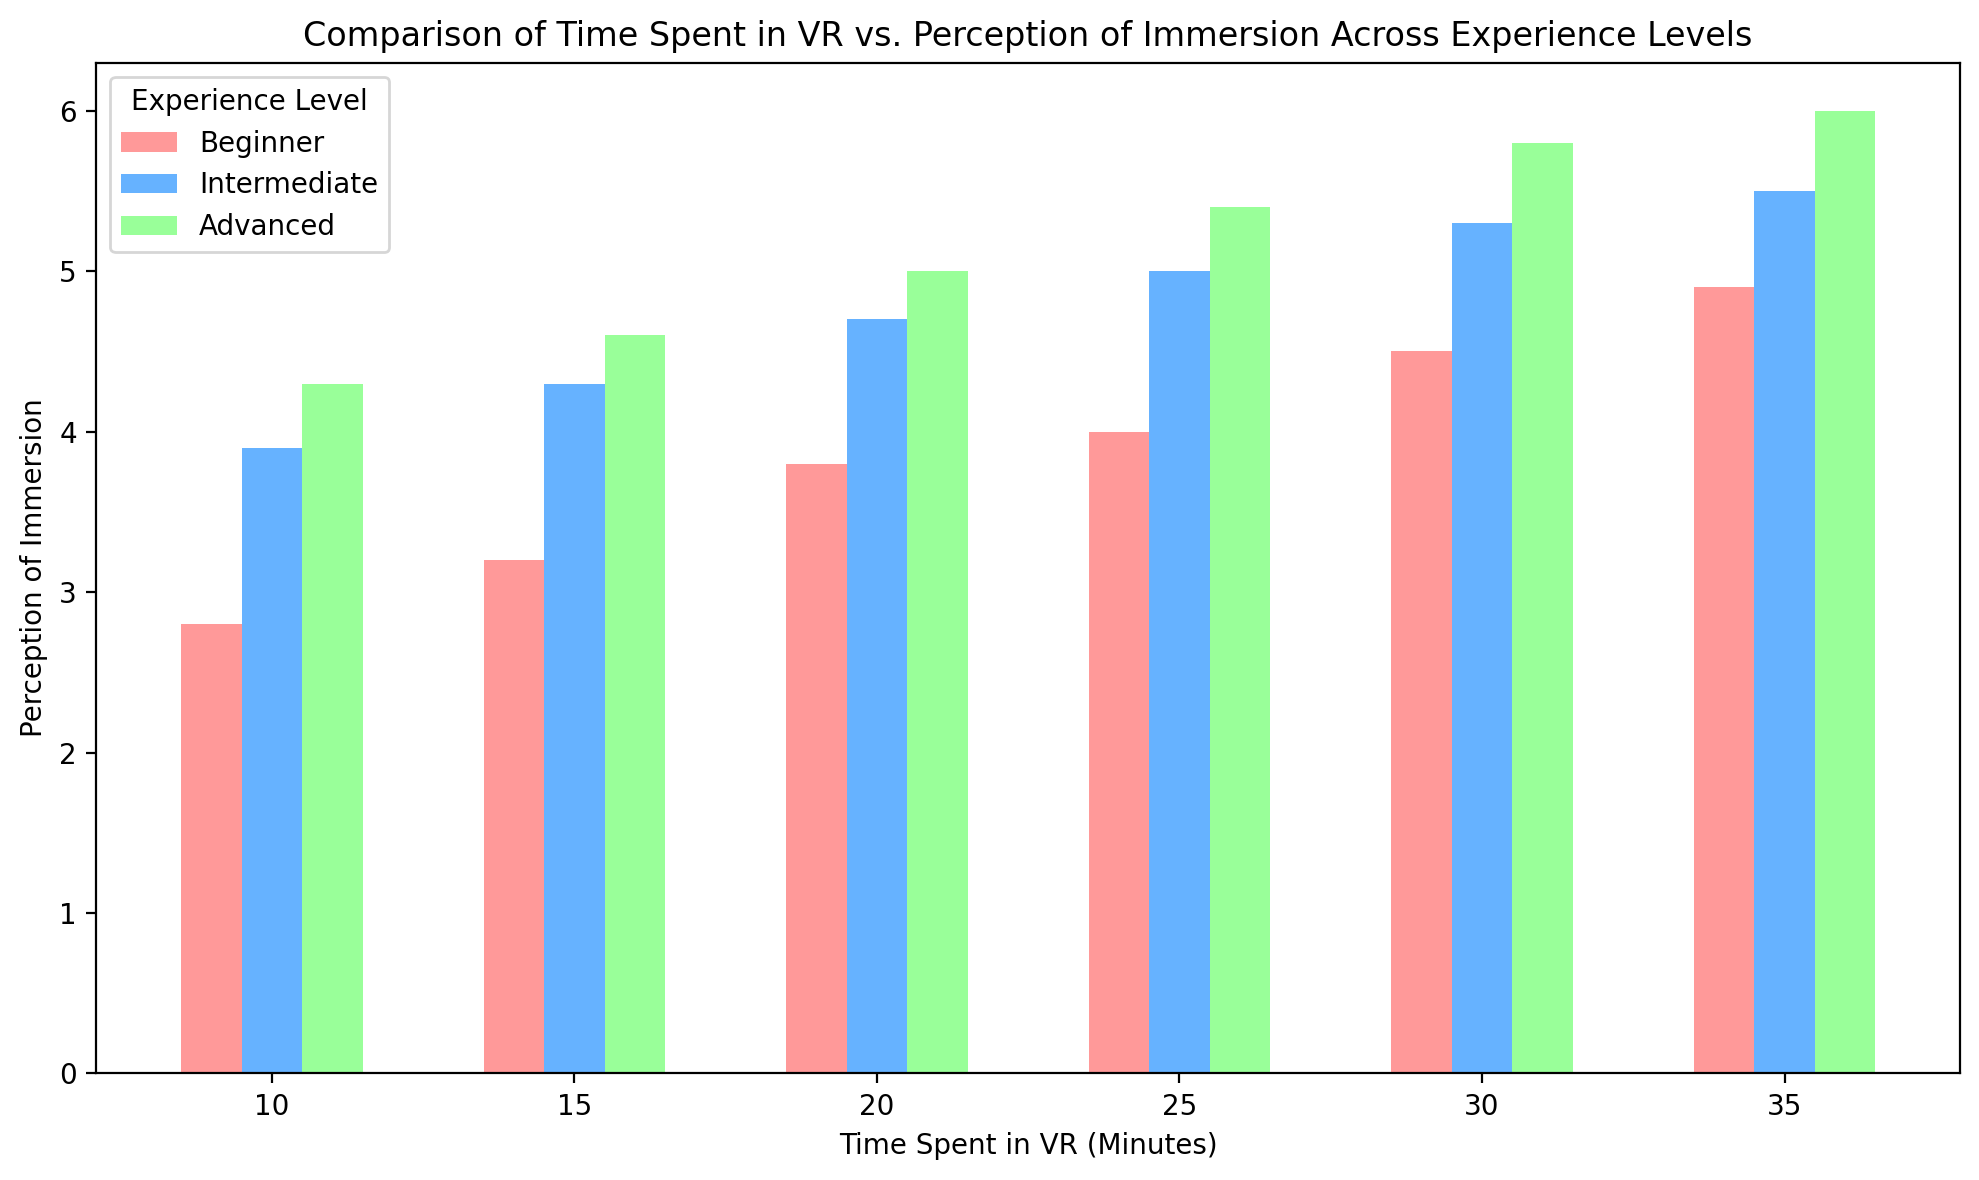What is the average perception of immersion for beginners when spending 20 minutes in VR? To find the average perception of immersion for beginners at 20 minutes, locate the bar for beginners at 20 minutes on the chart. The height of this bar represents the average perception of immersion.
Answer: 3.8 Which experience level shows the highest perception of immersion at 25 minutes? Look for the tallest bar at the 25-minute mark on the x-axis. The tallest bar represents the experience level with the highest perception of immersion at that time.
Answer: Advanced Compare the perception of immersion for intermediate users at 20 minutes and 35 minutes. Which is higher, and by how much? Find the bars for intermediate users at 20 and 35 minutes. Note their heights, subtract the value at 20 minutes from the value at 35 minutes to find the difference.
Answer: Intermediate at 35 minutes is higher by 0.8 (5.5 - 4.7) What is the total perception of immersion score for advanced users at 10, 20, and 30 minutes combined? Locate the bars for advanced users at 10, 20, and 30 minutes. Add their heights to get the total perception score.
Answer: 16.1 (4.3 + 5.0 + 5.8) Which experience level has the lowest average perception of immersion at 15 minutes? Compare the heights of the bars for each experience level at 15 minutes. The shortest bar represents the lowest average perception of immersion at that time.
Answer: Beginner By how much does the perception of immersion increase for beginners from 15 minutes to 30 minutes in VR? Identify the bars for beginners at 15 and 30 minutes. Subtract the height at 15 minutes from the height at 30 minutes to find the increase.
Answer: 1.3 (4.5 - 3.2) Is the perception of immersion for advanced users always higher than that for intermediate users across all time points? Visually compare the heights of the bars for advanced and intermediate users at each time point.
Answer: Yes What is the difference in perception of immersion between the highest and lowest experience levels at 35 minutes? Find the bars for advanced and beginner users at 35 minutes. Subtract the height of the beginner bar from the height of the advanced bar.
Answer: 1.1 (6.0 - 4.9) Rank the experience levels from highest to lowest based on their perception of immersion at 20 minutes. Compare the bars for each experience level at 20 minutes and sort them by height from tallest to shortest.
Answer: Advanced, Intermediate, Beginner On average, how do intermediate users' perceptions of immersion compare at 10 minutes versus 30 minutes? Find the heights of the bars for intermediate users at 10 and 30 minutes. Compare the heights to determine which is higher and by how much.
Answer: Perception at 30 minutes is higher by 1.4 (5.3 - 3.9) 